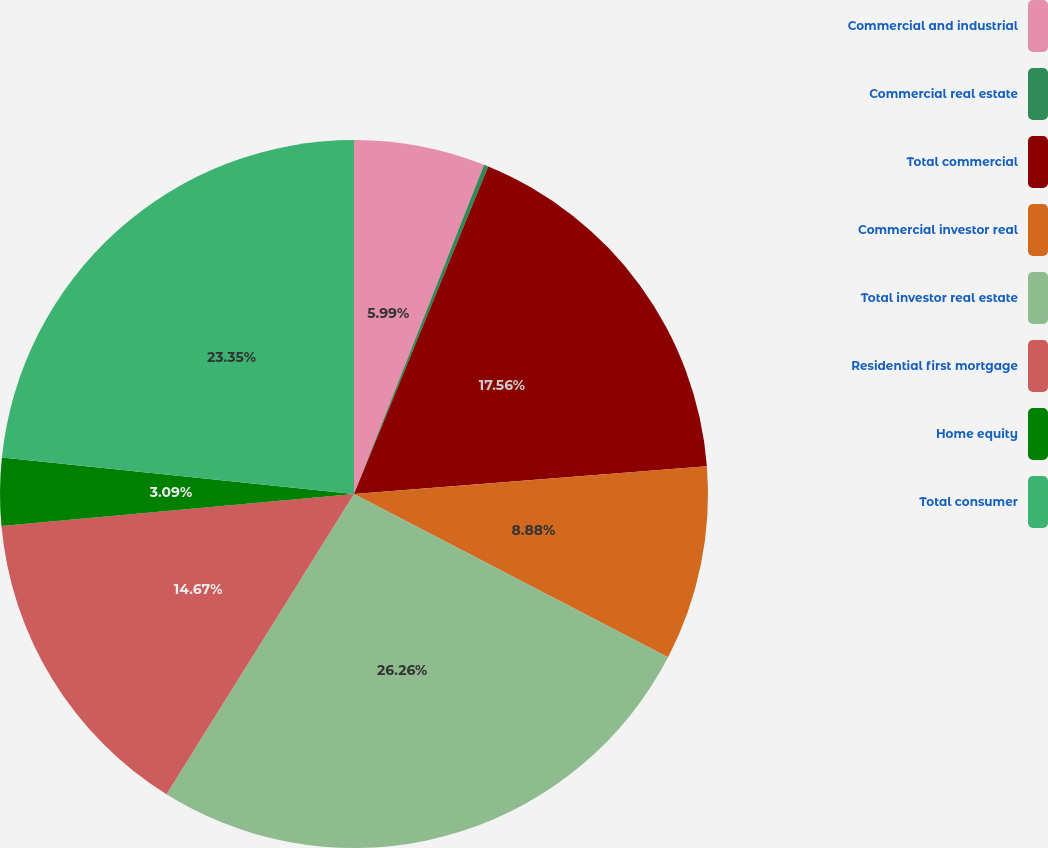Convert chart. <chart><loc_0><loc_0><loc_500><loc_500><pie_chart><fcel>Commercial and industrial<fcel>Commercial real estate<fcel>Total commercial<fcel>Commercial investor real<fcel>Total investor real estate<fcel>Residential first mortgage<fcel>Home equity<fcel>Total consumer<nl><fcel>5.99%<fcel>0.2%<fcel>17.56%<fcel>8.88%<fcel>26.25%<fcel>14.67%<fcel>3.09%<fcel>23.35%<nl></chart> 